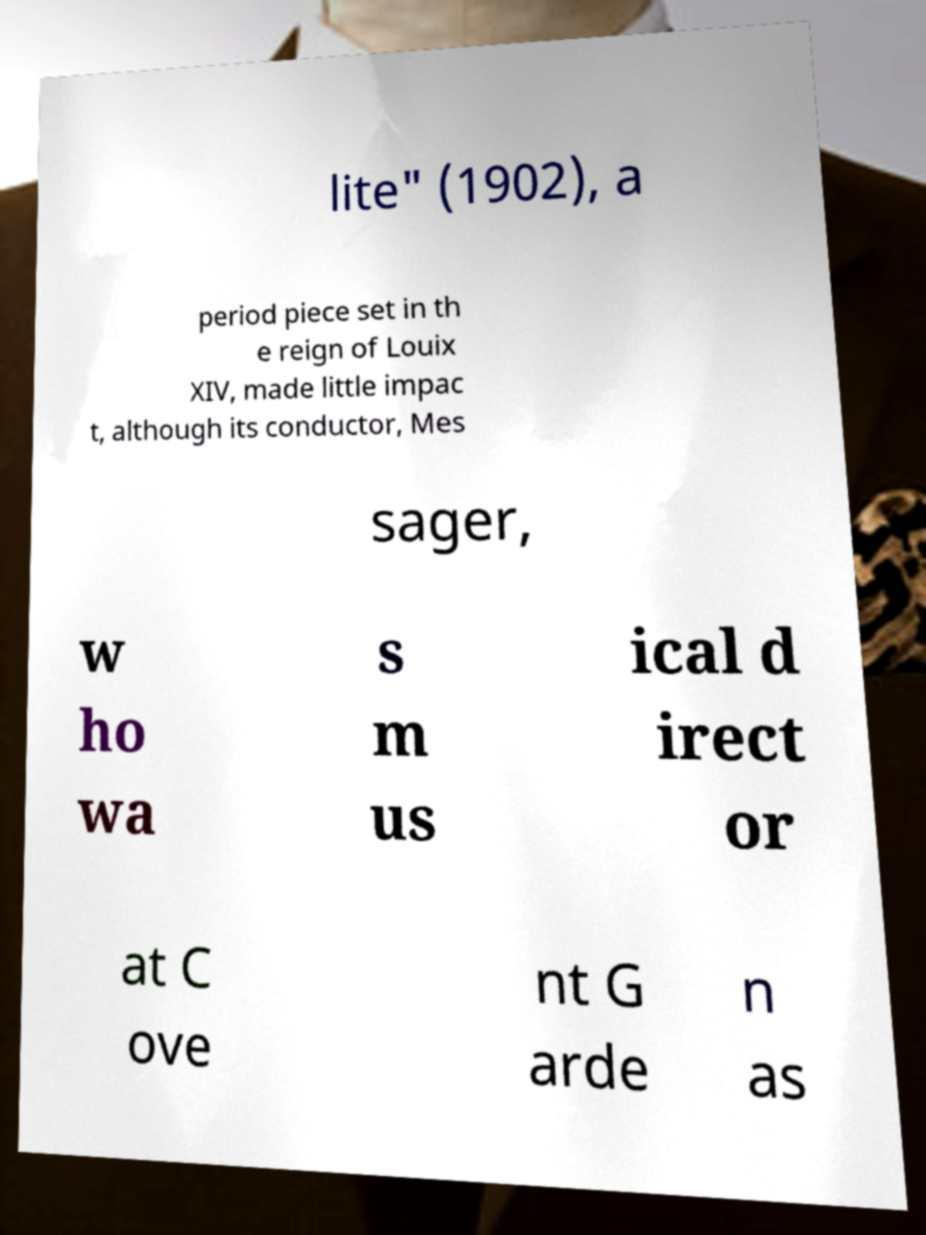Please identify and transcribe the text found in this image. lite" (1902), a period piece set in th e reign of Louix XIV, made little impac t, although its conductor, Mes sager, w ho wa s m us ical d irect or at C ove nt G arde n as 